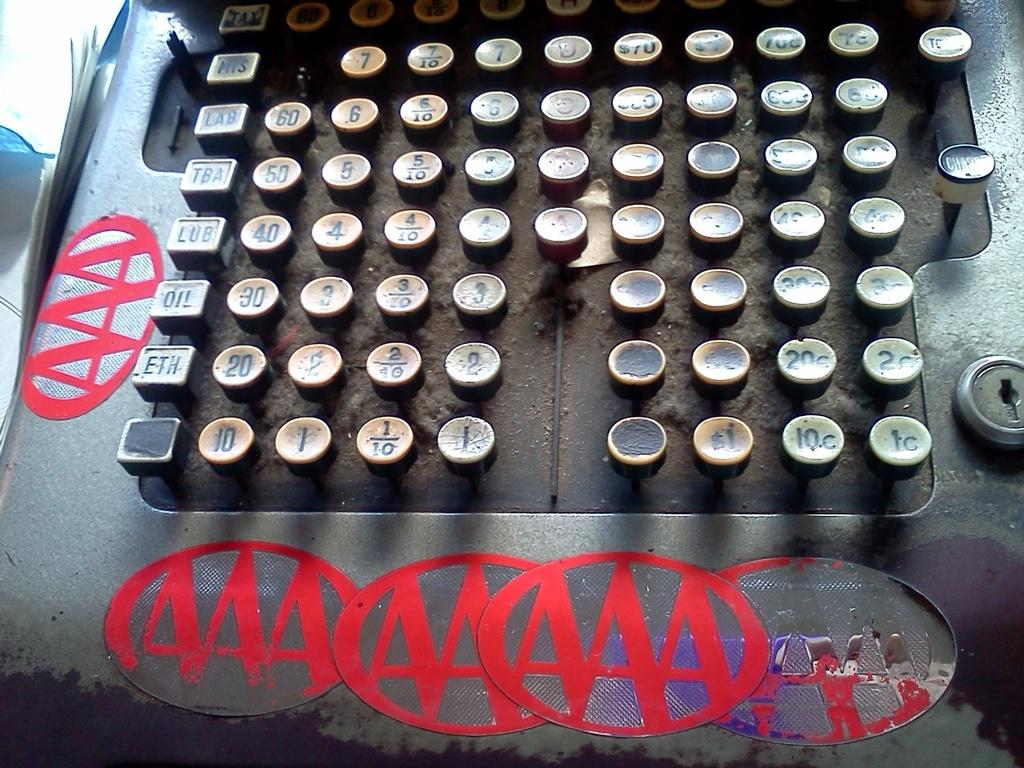Provide a one-sentence caption for the provided image. An antique cash register with five old AAA stickers around the edges. 